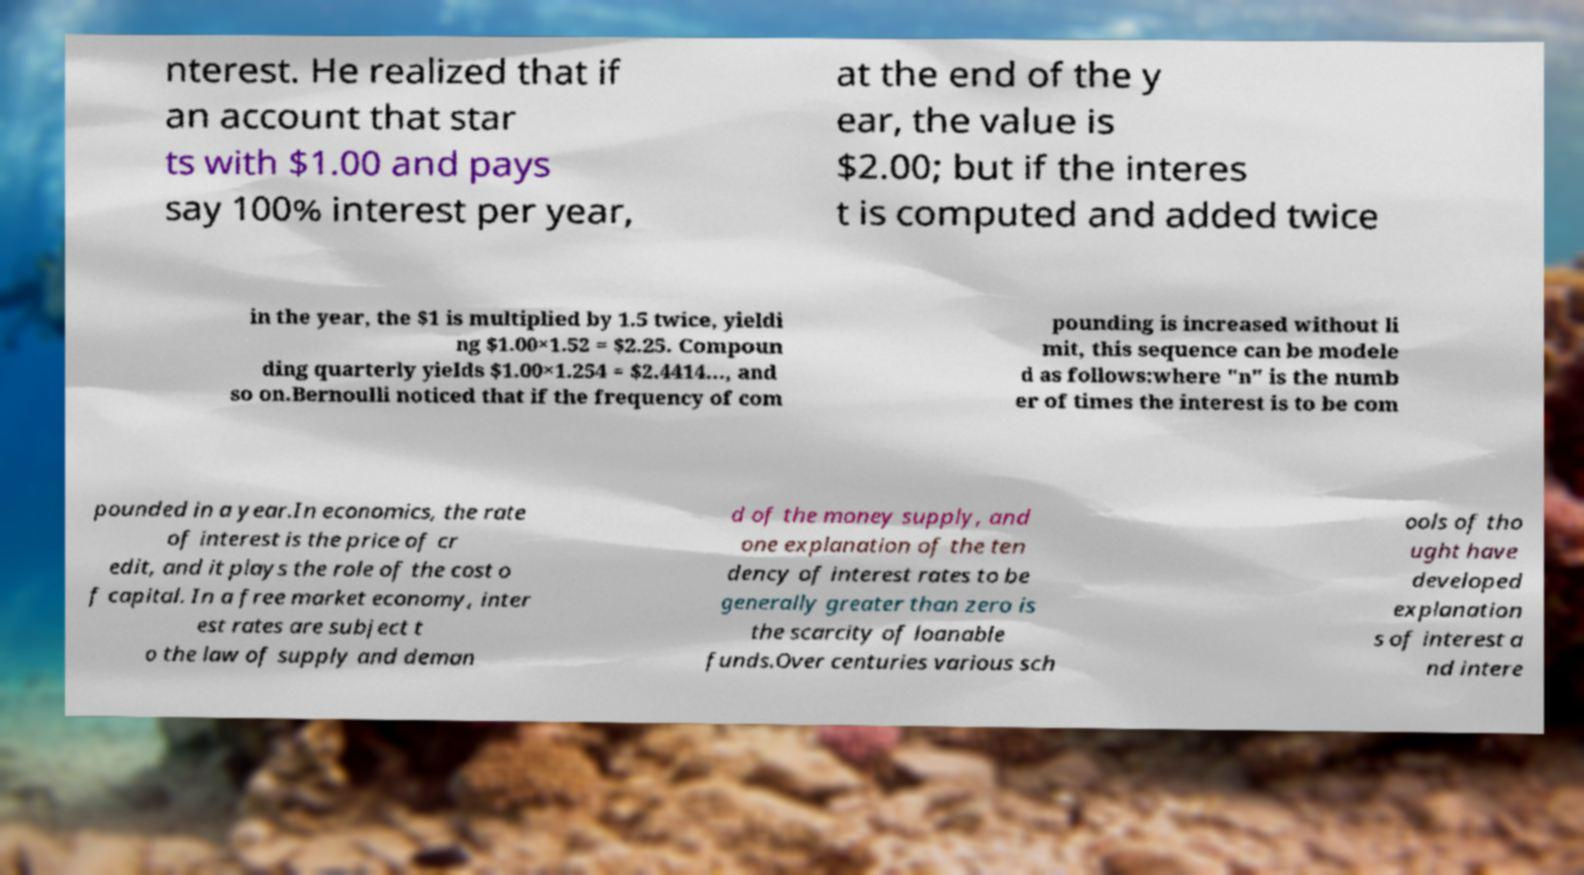Please identify and transcribe the text found in this image. nterest. He realized that if an account that star ts with $1.00 and pays say 100% interest per year, at the end of the y ear, the value is $2.00; but if the interes t is computed and added twice in the year, the $1 is multiplied by 1.5 twice, yieldi ng $1.00×1.52 = $2.25. Compoun ding quarterly yields $1.00×1.254 = $2.4414..., and so on.Bernoulli noticed that if the frequency of com pounding is increased without li mit, this sequence can be modele d as follows:where "n" is the numb er of times the interest is to be com pounded in a year.In economics, the rate of interest is the price of cr edit, and it plays the role of the cost o f capital. In a free market economy, inter est rates are subject t o the law of supply and deman d of the money supply, and one explanation of the ten dency of interest rates to be generally greater than zero is the scarcity of loanable funds.Over centuries various sch ools of tho ught have developed explanation s of interest a nd intere 